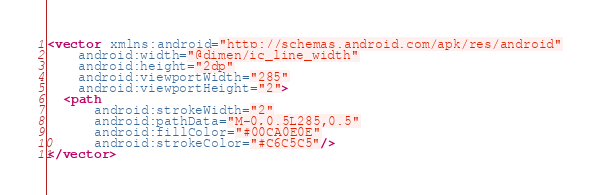<code> <loc_0><loc_0><loc_500><loc_500><_XML_><vector xmlns:android="http://schemas.android.com/apk/res/android"
    android:width="@dimen/ic_line_width"
    android:height="2dp"
    android:viewportWidth="285"
    android:viewportHeight="2">
  <path
      android:strokeWidth="2"
      android:pathData="M-0,0.5L285,0.5"
      android:fillColor="#00CA0E0E"
      android:strokeColor="#C6C5C5"/>
</vector>
</code> 